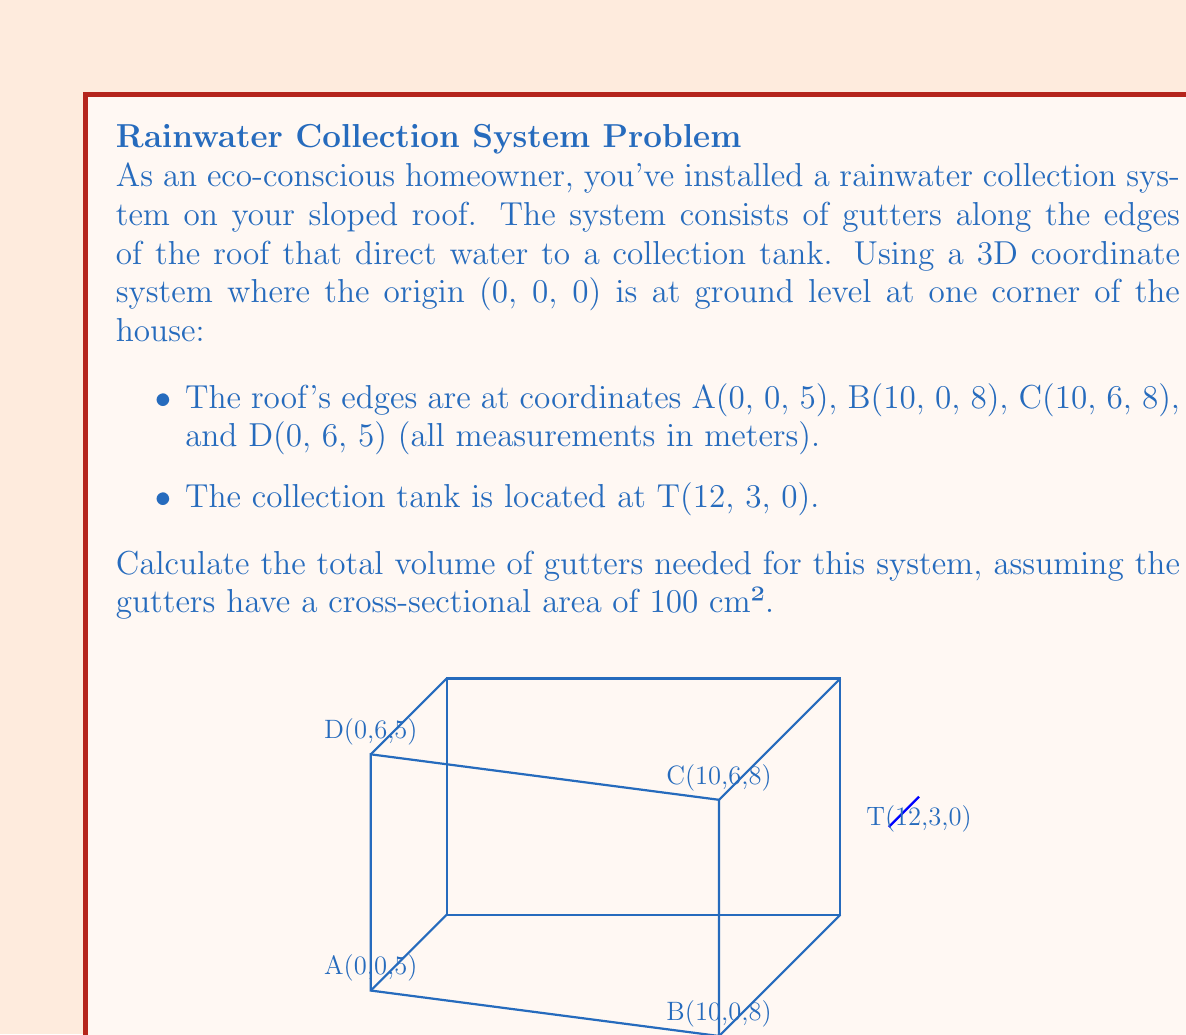Can you solve this math problem? To solve this problem, we need to calculate the total length of the gutters and then multiply it by the cross-sectional area. Let's break it down step-by-step:

1) First, we need to calculate the length of each edge of the roof where gutters will be installed. We can use the distance formula in 3D space:
   $d = \sqrt{(x_2-x_1)^2 + (y_2-y_1)^2 + (z_2-z_1)^2}$

2) Calculate length AB:
   $AB = \sqrt{(10-0)^2 + (0-0)^2 + (8-5)^2} = \sqrt{100 + 0 + 9} = \sqrt{109} \approx 10.44$ m

3) Calculate length BC:
   $BC = \sqrt{(10-10)^2 + (6-0)^2 + (8-8)^2} = \sqrt{0 + 36 + 0} = 6$ m

4) Calculate length CD:
   $CD = \sqrt{(0-10)^2 + (6-6)^2 + (5-8)^2} = \sqrt{100 + 0 + 9} = \sqrt{109} \approx 10.44$ m

5) Calculate length DA:
   $DA = \sqrt{(0-0)^2 + (6-0)^2 + (5-5)^2} = \sqrt{0 + 36 + 0} = 6$ m

6) Total length of gutters:
   $L_{total} = AB + BC + CD + DA = 10.44 + 6 + 10.44 + 6 = 32.88$ m

7) Convert the cross-sectional area from cm² to m²:
   $A = 100 \text{ cm}^2 = 0.01 \text{ m}^2$

8) Calculate the total volume:
   $V = L_{total} \times A = 32.88 \text{ m} \times 0.01 \text{ m}^2 = 0.3288 \text{ m}^3$

9) Convert to liters:
   $V = 0.3288 \text{ m}^3 \times 1000 \text{ L/m}^3 = 328.8 \text{ L}$
Answer: 328.8 L 